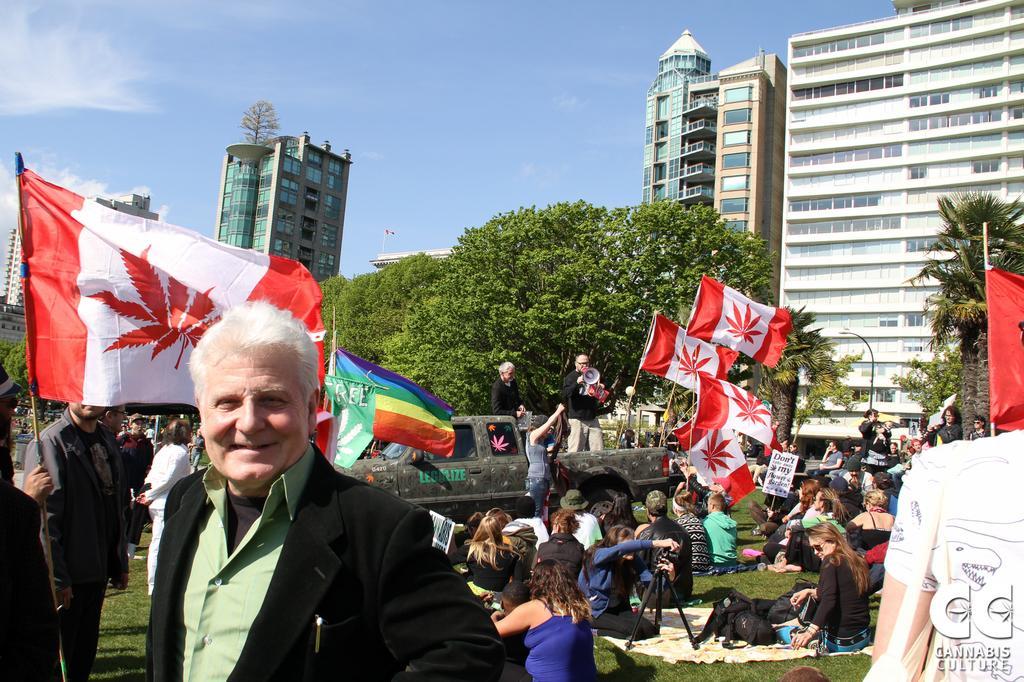Describe this image in one or two sentences. In this image I see number of people and I see flags which are of white and red in color and I see the green grass and I see vehicle over here. In the background I see the trees, buildings and the clear sky. 